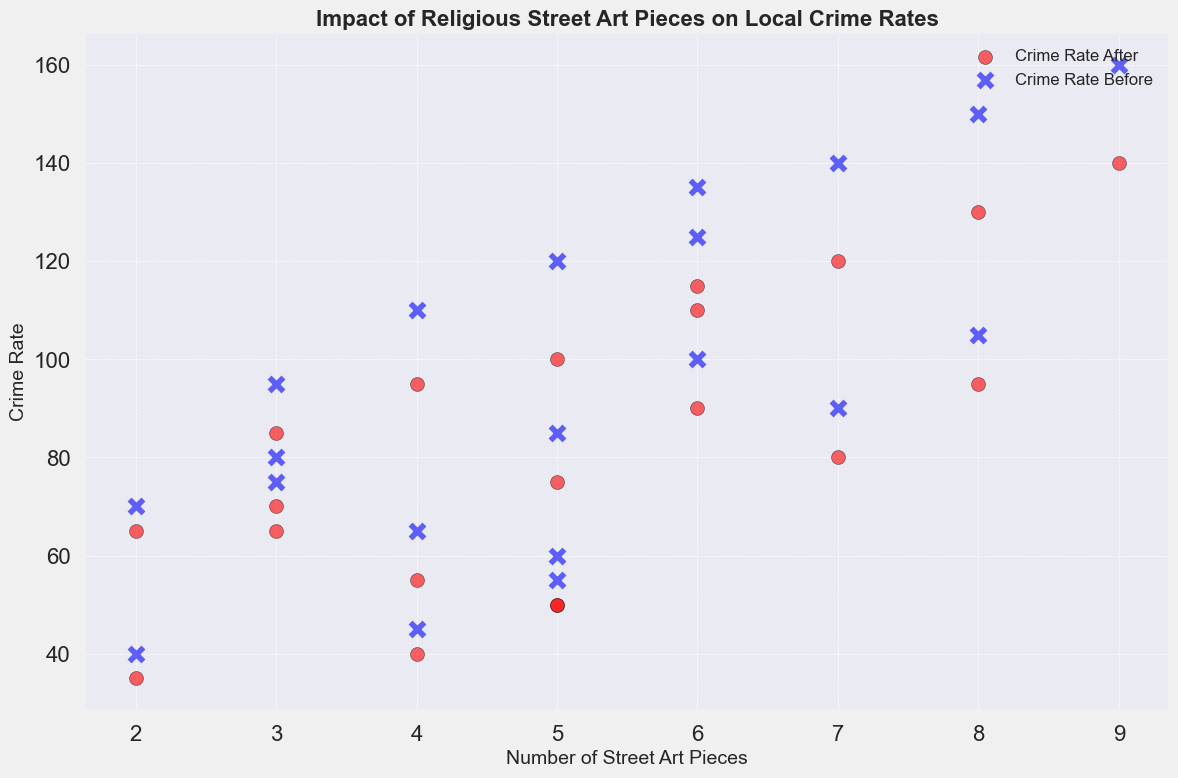What is the relationship between the number of street art pieces and the crime rate after the installation of the art? To determine the relationship, one should compare the number of street art pieces (x-axis) with the crime rate after installation (red circles). The overall trend should be observed. The data points suggest that as the number of street art pieces increases, the crime rate after installation generally decreases.
Answer: Inverse relationship Which location saw the largest decrease in crime rate? To find the largest decrease, calculate the difference between the crime rate before and after for each location by observing the blue 'x' and red 'circle' positions. School District has the largest drop from 160 to 140, presenting a decrease of 20.
Answer: School District How does the community safety score before and after installation relate to the number of street art pieces? Although community safety scores are not directly plotted, they can be indirectly inferred. Generally, locations with more street art pieces (higher x-axis values) have shown improvements in safety scores, which is consistent with seeing a reduction in crime rates post-installation of street art.
Answer: Improvement Which locations had exactly 5 street art pieces and what was the corresponding crime rate after installation for these locations? Identify the locations with 5 street art pieces (x=5) and read the corresponding red circle values. Locations are Downtown Area, Riverside, Northern Suburb, and Cultural Center, with crime rates after installation of 100, 75, 50, and 50 respectively.
Answer: Downtown Area: 100, Riverside: 75, Northern Suburb: 50, Cultural Center: 50 Did any location see an increase in crime rate after street art installation? Inspect the red circles, which should be mostly lower than or equal to the blue 'x' values for the same number of street art pieces. None of the locations show an increase as every red circle is below or equal to the blue 'x'.
Answer: No Which location had the highest crime rate after installation and how many street art pieces were there? Look for the highest red circle on the y-axis, which is 140 in the School District. Correspondingly, the number of street art pieces installed was 9.
Answer: School District, 140 If you average the crime rate before and after installation across all locations with 7 street art pieces, what would it be? For locations with 7 street art pieces, their crime rates before installation are 140, 90, and 125, and after installation are 120, 80, and 110. Average the before rates: (140 + 90 + 125) / 3 = 118.33; Average the after rates: (120 + 80 + 110) / 3 = 103.33
Answer: 118.33 (before), 103.33 (after) Is there a visual indication that community safety perception improved as street art pieces were installed? Various visual cues can be observed since the crime rate after installation (red circles) generally decreases from the crime rate before installation (blue 'x'). This suggests an improvement in safety perception as crime rates dropped.
Answer: Yes 